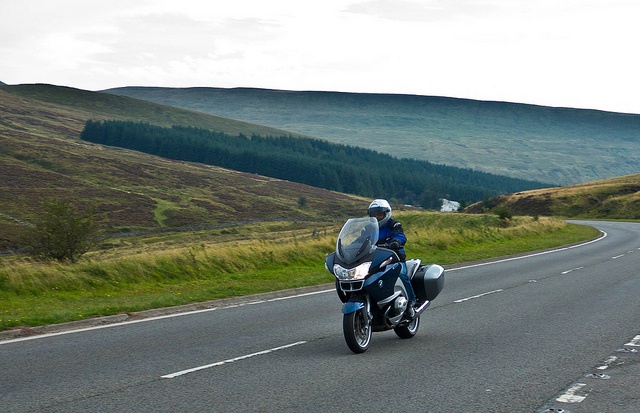Describe the objects in this image and their specific colors. I can see motorcycle in white, black, gray, blue, and darkgray tones and people in white, black, navy, and blue tones in this image. 